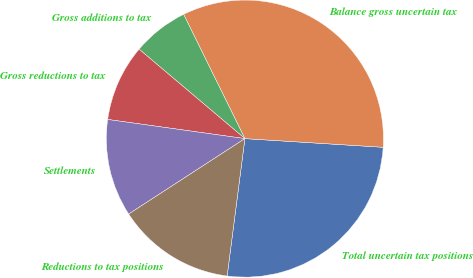Convert chart. <chart><loc_0><loc_0><loc_500><loc_500><pie_chart><fcel>Total uncertain tax positions<fcel>Balance gross uncertain tax<fcel>Gross additions to tax<fcel>Gross reductions to tax<fcel>Settlements<fcel>Reductions to tax positions<nl><fcel>26.05%<fcel>33.29%<fcel>6.54%<fcel>8.96%<fcel>11.37%<fcel>13.79%<nl></chart> 